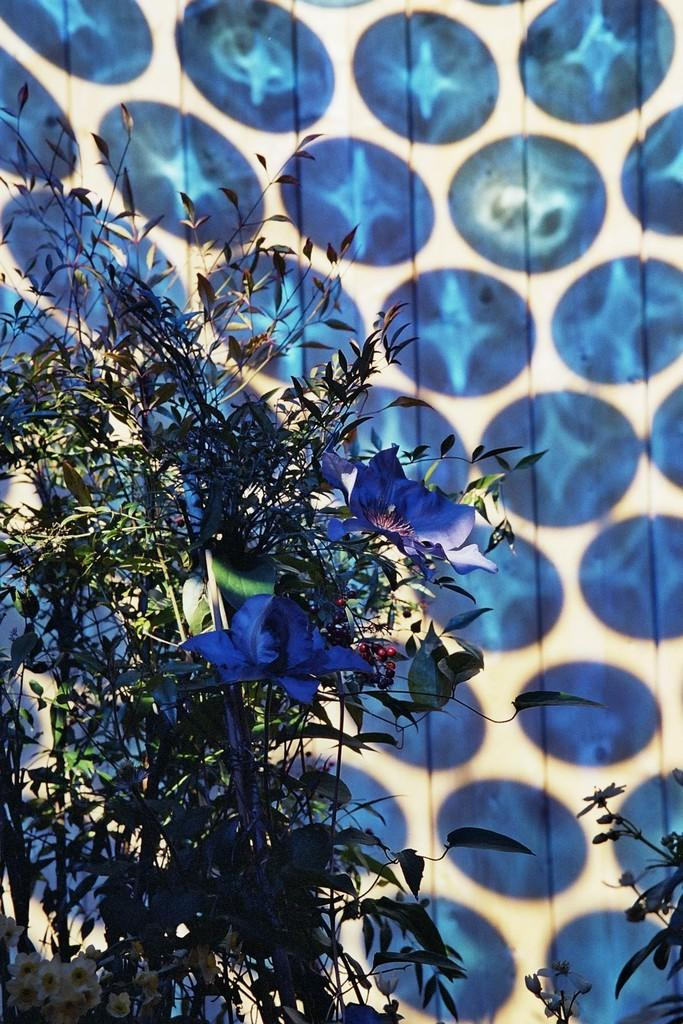What is located in the front of the image? There are plants in the front of the image. What can be seen in the background of the image? There is an object in the background of the image. What colors are present on the object in the background? The object has a white and blue color. What type of amusement can be seen in the image? There is no amusement present in the image; it features plants in the front and an object with a white and blue color in the background. What caption is written on the plants in the image? There is no caption written on the plants in the image; they are simply plants. 